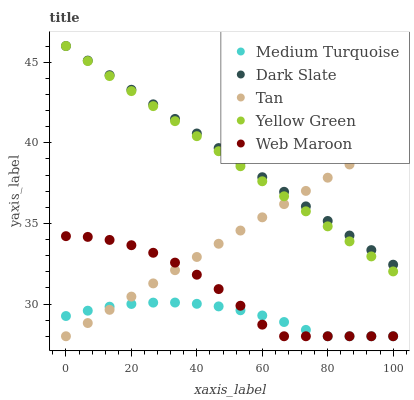Does Medium Turquoise have the minimum area under the curve?
Answer yes or no. Yes. Does Dark Slate have the maximum area under the curve?
Answer yes or no. Yes. Does Tan have the minimum area under the curve?
Answer yes or no. No. Does Tan have the maximum area under the curve?
Answer yes or no. No. Is Dark Slate the smoothest?
Answer yes or no. Yes. Is Web Maroon the roughest?
Answer yes or no. Yes. Is Tan the smoothest?
Answer yes or no. No. Is Tan the roughest?
Answer yes or no. No. Does Tan have the lowest value?
Answer yes or no. Yes. Does Yellow Green have the lowest value?
Answer yes or no. No. Does Yellow Green have the highest value?
Answer yes or no. Yes. Does Tan have the highest value?
Answer yes or no. No. Is Medium Turquoise less than Dark Slate?
Answer yes or no. Yes. Is Dark Slate greater than Medium Turquoise?
Answer yes or no. Yes. Does Tan intersect Dark Slate?
Answer yes or no. Yes. Is Tan less than Dark Slate?
Answer yes or no. No. Is Tan greater than Dark Slate?
Answer yes or no. No. Does Medium Turquoise intersect Dark Slate?
Answer yes or no. No. 